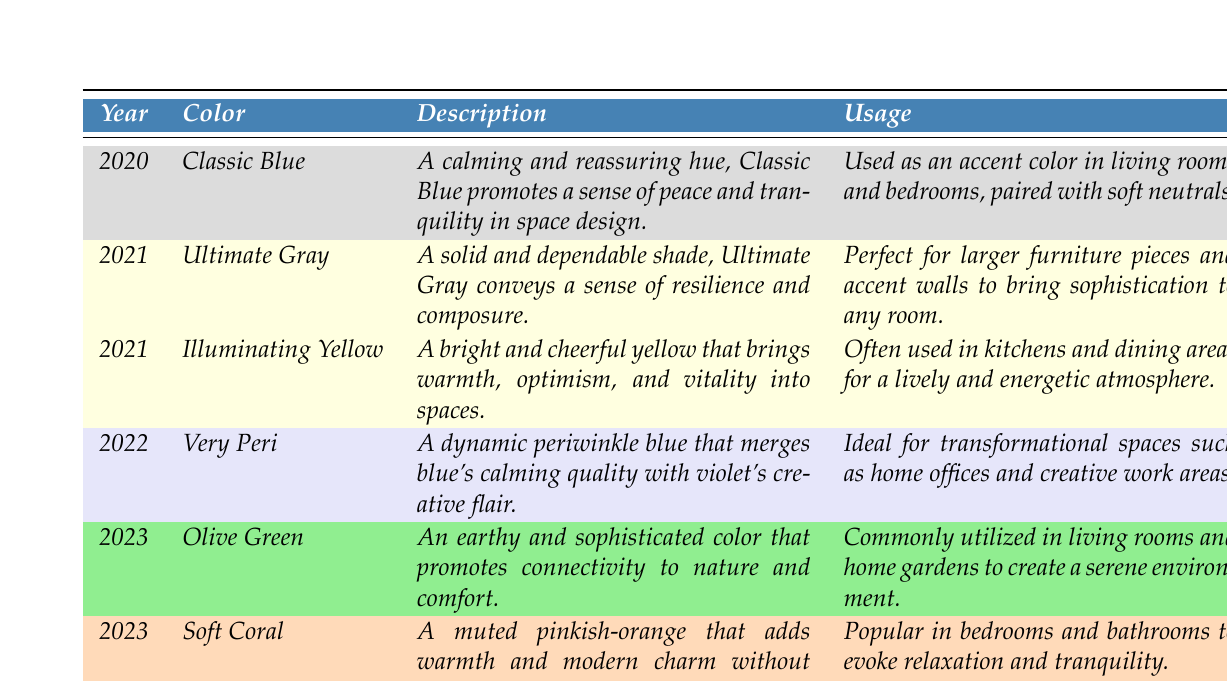What color was highlighted in 2020? Referring to the table, the color listed for the year 2020 is Classic Blue.
Answer: Classic Blue Which color was used in 2021 besides Ultimate Gray? Looking at the table, in 2021, the other color listed is Illuminating Yellow.
Answer: Illuminating Yellow How many different colors were featured in 2023? The table shows two colors for the year 2023: Olive Green and Soft Coral.
Answer: 2 What is the usage of Ultimate Gray? The table specifies that Ultimate Gray is perfect for larger furniture pieces and accent walls.
Answer: Larger furniture pieces and accent walls Is Very Peri associated with a specific room type? Yes, the table indicates that Very Peri is ideal for transformational spaces such as home offices.
Answer: Yes What are the descriptions of the colors used in 2023? The table provides descriptions for both colors in 2023: Olive Green promotes connectivity to nature and comfort, while Soft Coral adds warmth and modern charm.
Answer: Olive Green: earthy and sophisticated; Soft Coral: muted pinkish-orange Which color from 2021 is associated with kitchens and dining areas? The table reveals that Illuminating Yellow is often used in kitchens and dining areas for a lively atmosphere.
Answer: Illuminating Yellow How would you summarize the trend from 2020 to 2023 regarding color tones? Observing the table shows a trend from calming tones like Classic Blue in 2020, to more vibrant and earthy tones such as Soft Coral and Olive Green in 2023.
Answer: From calming to vibrant and earthy tones What is the contrast in the color themes from 2020 to 2023? Analyzing the data, 2020 emphasized tranquility with Classic Blue, while 2023 features earthy and warm tones like Olive Green and Soft Coral.
Answer: Shift from tranquility to earthy and warm tones In which components of the living spaces is Soft Coral commonly utilized according to the table? The table mentions that Soft Coral is popular in bedrooms and bathrooms to evoke relaxation and tranquility.
Answer: Bedrooms and bathrooms Which color has a description that includes the phrase "promotes connectivity to nature"? Looking at the table, Olive Green has a description that includes "promotes connectivity to nature."
Answer: Olive Green 